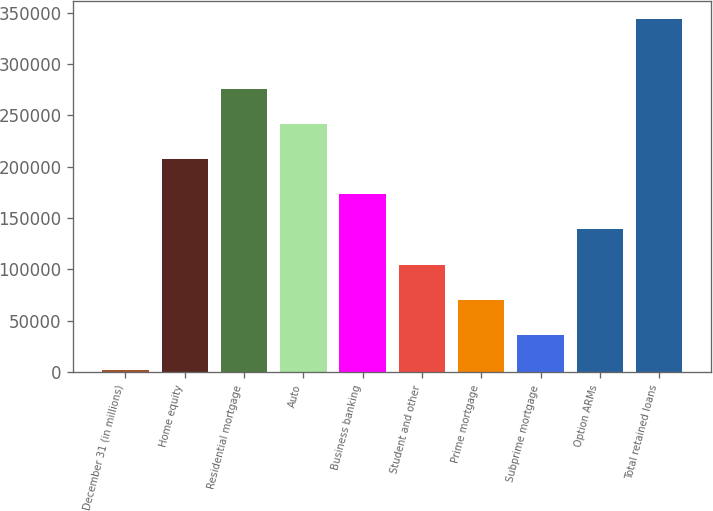<chart> <loc_0><loc_0><loc_500><loc_500><bar_chart><fcel>December 31 (in millions)<fcel>Home equity<fcel>Residential mortgage<fcel>Auto<fcel>Business banking<fcel>Student and other<fcel>Prime mortgage<fcel>Subprime mortgage<fcel>Option ARMs<fcel>Total retained loans<nl><fcel>2015<fcel>207419<fcel>275887<fcel>241653<fcel>173185<fcel>104717<fcel>70483<fcel>36249<fcel>138951<fcel>344355<nl></chart> 